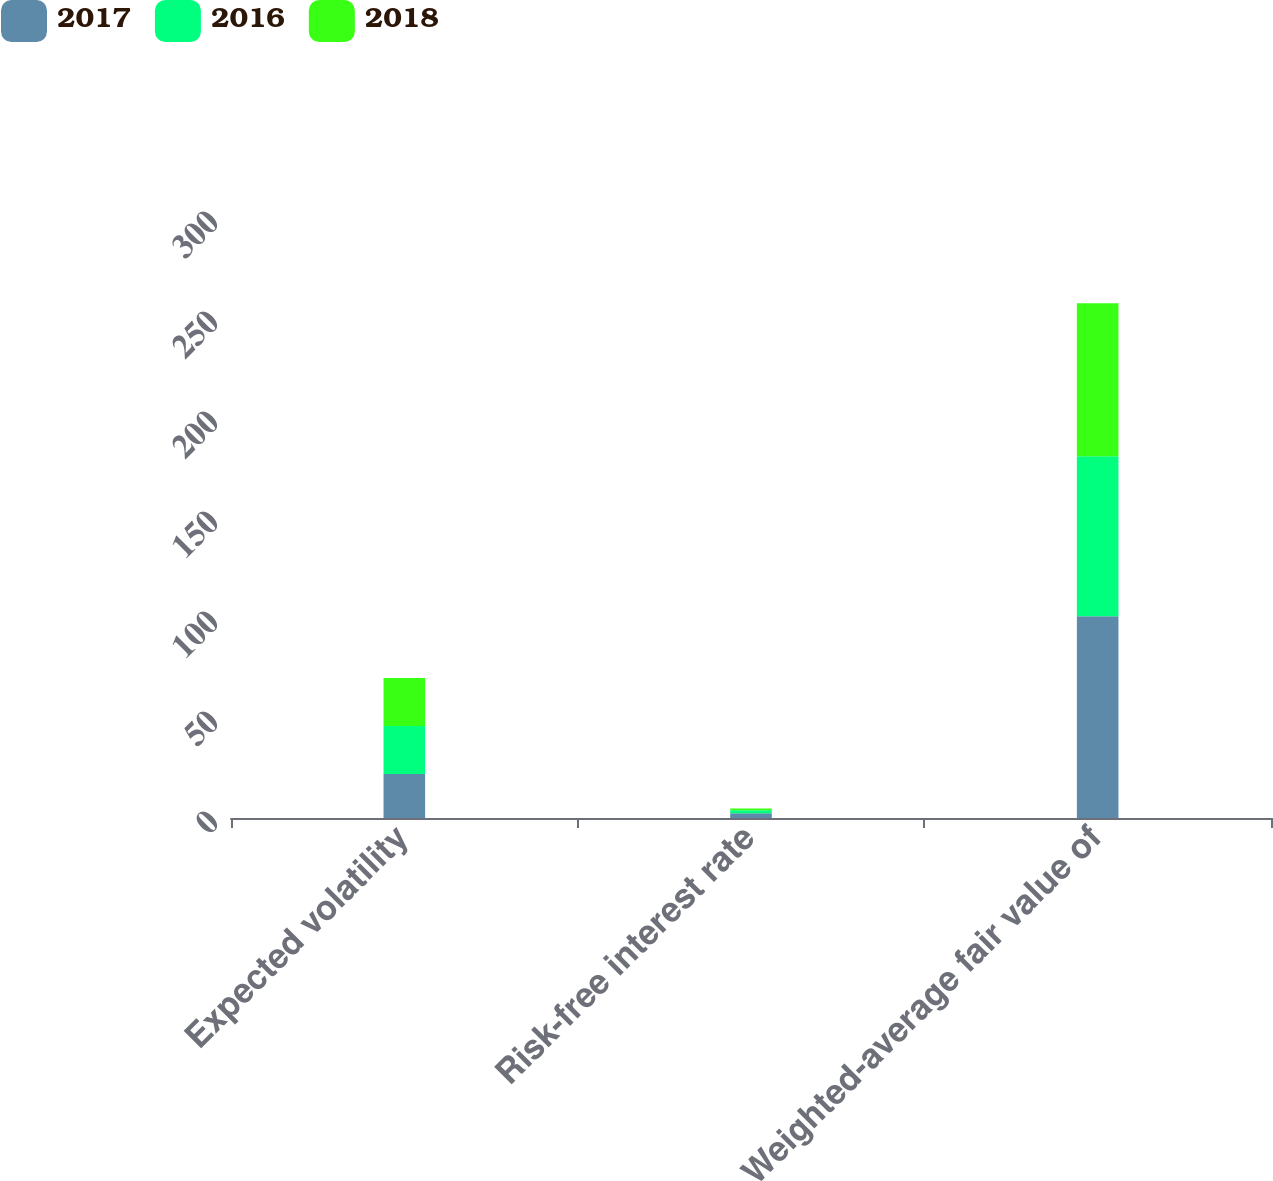Convert chart to OTSL. <chart><loc_0><loc_0><loc_500><loc_500><stacked_bar_chart><ecel><fcel>Expected volatility<fcel>Risk-free interest rate<fcel>Weighted-average fair value of<nl><fcel>2017<fcel>22<fcel>2.38<fcel>100.86<nl><fcel>2016<fcel>24<fcel>1.46<fcel>80.07<nl><fcel>2018<fcel>24<fcel>0.88<fcel>76.41<nl></chart> 